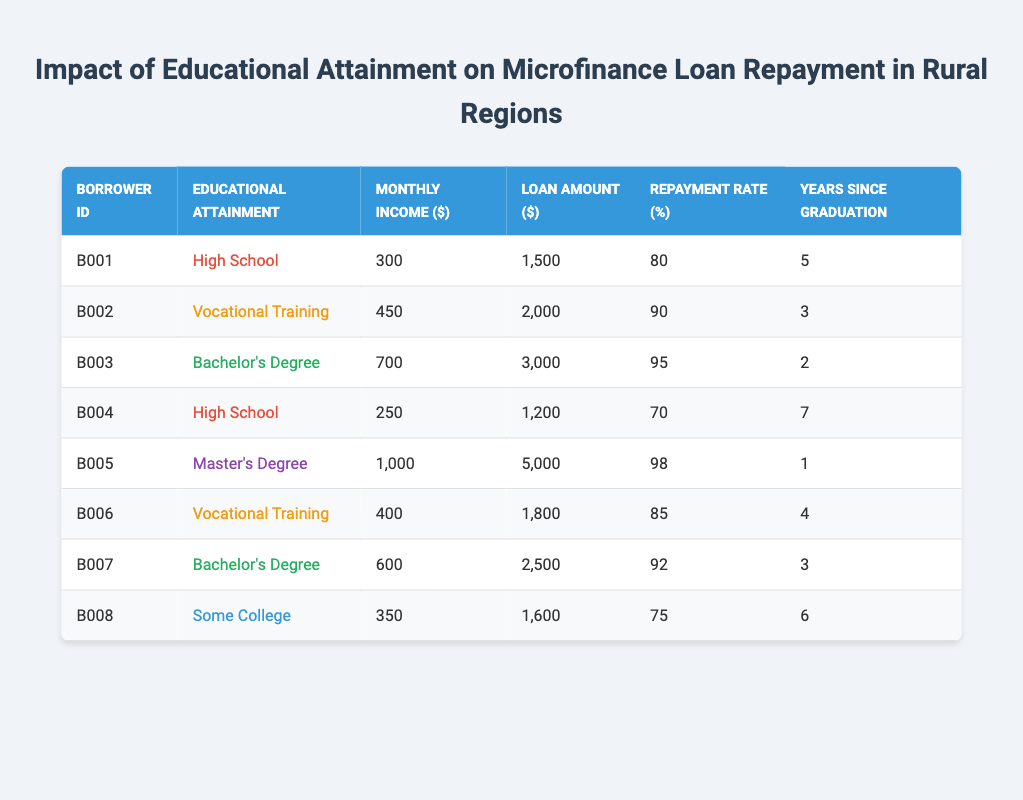What is the repayment rate for the borrower with ID B005? Looking at the table, the borrower with ID B005 has a repayment rate listed under the column "Repayment Rate (%)" as 98.
Answer: 98 How many borrowers have a Bachelor's degree? By scanning the educational attainment column, we can identify that there are 2 borrowers with a Bachelor's Degree (B003 and B007).
Answer: 2 What is the average monthly income for those who completed Vocational Training? The monthly incomes for borrowers with Vocational Training (B002 and B006) are 450 and 400, respectively. Summing these gives us 450 + 400 = 850. Dividing that total by 2 (the number of borrowers) yields an average of 850 / 2 = 425.
Answer: 425 Is there any borrower with a repayment rate higher than 90%? Reviewing the repayment rate column, we observe that B002, B003, B005, and B007 have repayment rates of 90 or higher (90, 95, 98, and 92 respectively). Therefore, the answer is yes.
Answer: Yes What is the difference in monthly income between the highest and lowest earning borrowers? The highest monthly income is from B005 at 1000, and the lowest is from B004 at 250. The difference is 1000 - 250 = 750.
Answer: 750 Which educational attainment group has the highest average repayment rate? To find this, we can calculate the average repayment rates for each educational group: High School (75 + 80)/2 = 75, Vocational Training (90 + 85)/2 = 87.5, Bachelor's Degree (95 + 92)/2 = 93.5, Master's Degree (98)/1 = 98, Some College (75)/1 = 75. The highest average repayment rate is for the Master's Degree group at 98.
Answer: Master's Degree How many borrowers have loan amounts greater than 2000? In the "Loan Amount ($)" column, we see that borrowers B003 (3000), B005 (5000), and B007 (2500) have loan amounts greater than 2000. Thus, there are 3 such borrowers.
Answer: 3 What is the average loan amount for borrowers with a High School education? The loan amounts for the borrowers B001 and B004 with a High School education are 1500 and 1200. Summing these gives 1500 + 1200 = 2700, and dividing by 2 yields an average of 2700 / 2 = 1350.
Answer: 1350 Is it true that all borrowers with a Master's Degree have a repayment rate of 98%? Looking at the table, the only borrower with a Master's degree is B005, and their repayment rate is indeed 98%. Therefore, the statement is true.
Answer: True 